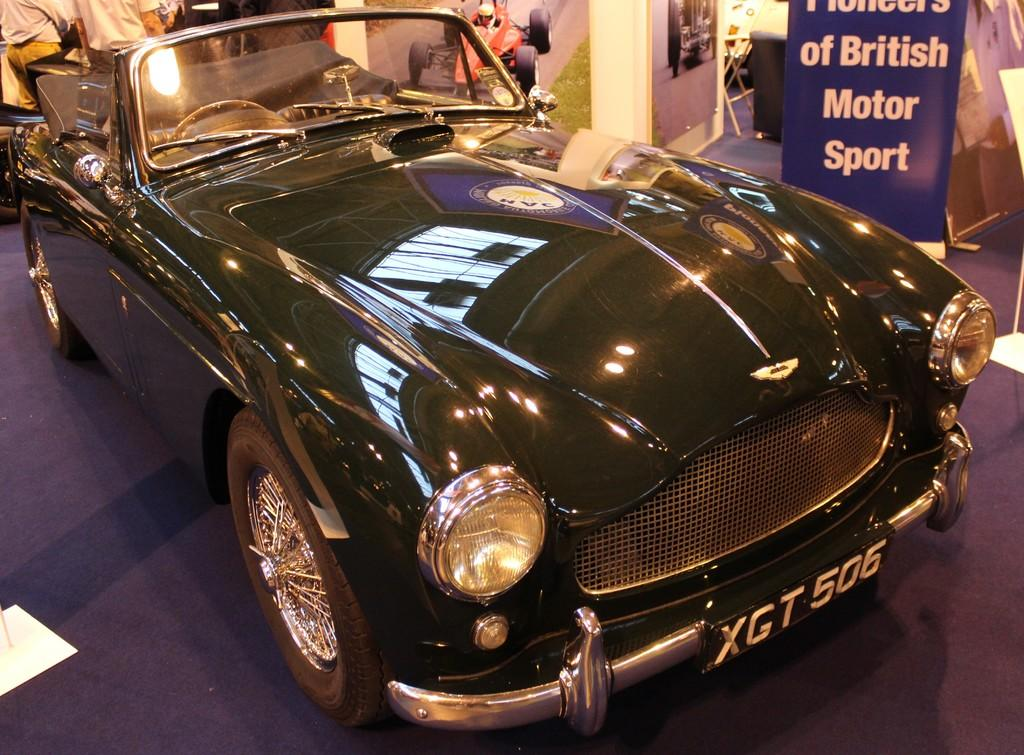What is the main subject in the image? There is a vehicle in the image. What are the other items visible in the image besides the vehicle? There are banners and posters in the image. Can you describe any other objects present in the image? Yes, there are other objects in the image. What is the price of the account associated with the vehicle in the image? There is no mention of an account or price in the image; it only features a vehicle, banners, and posters. 